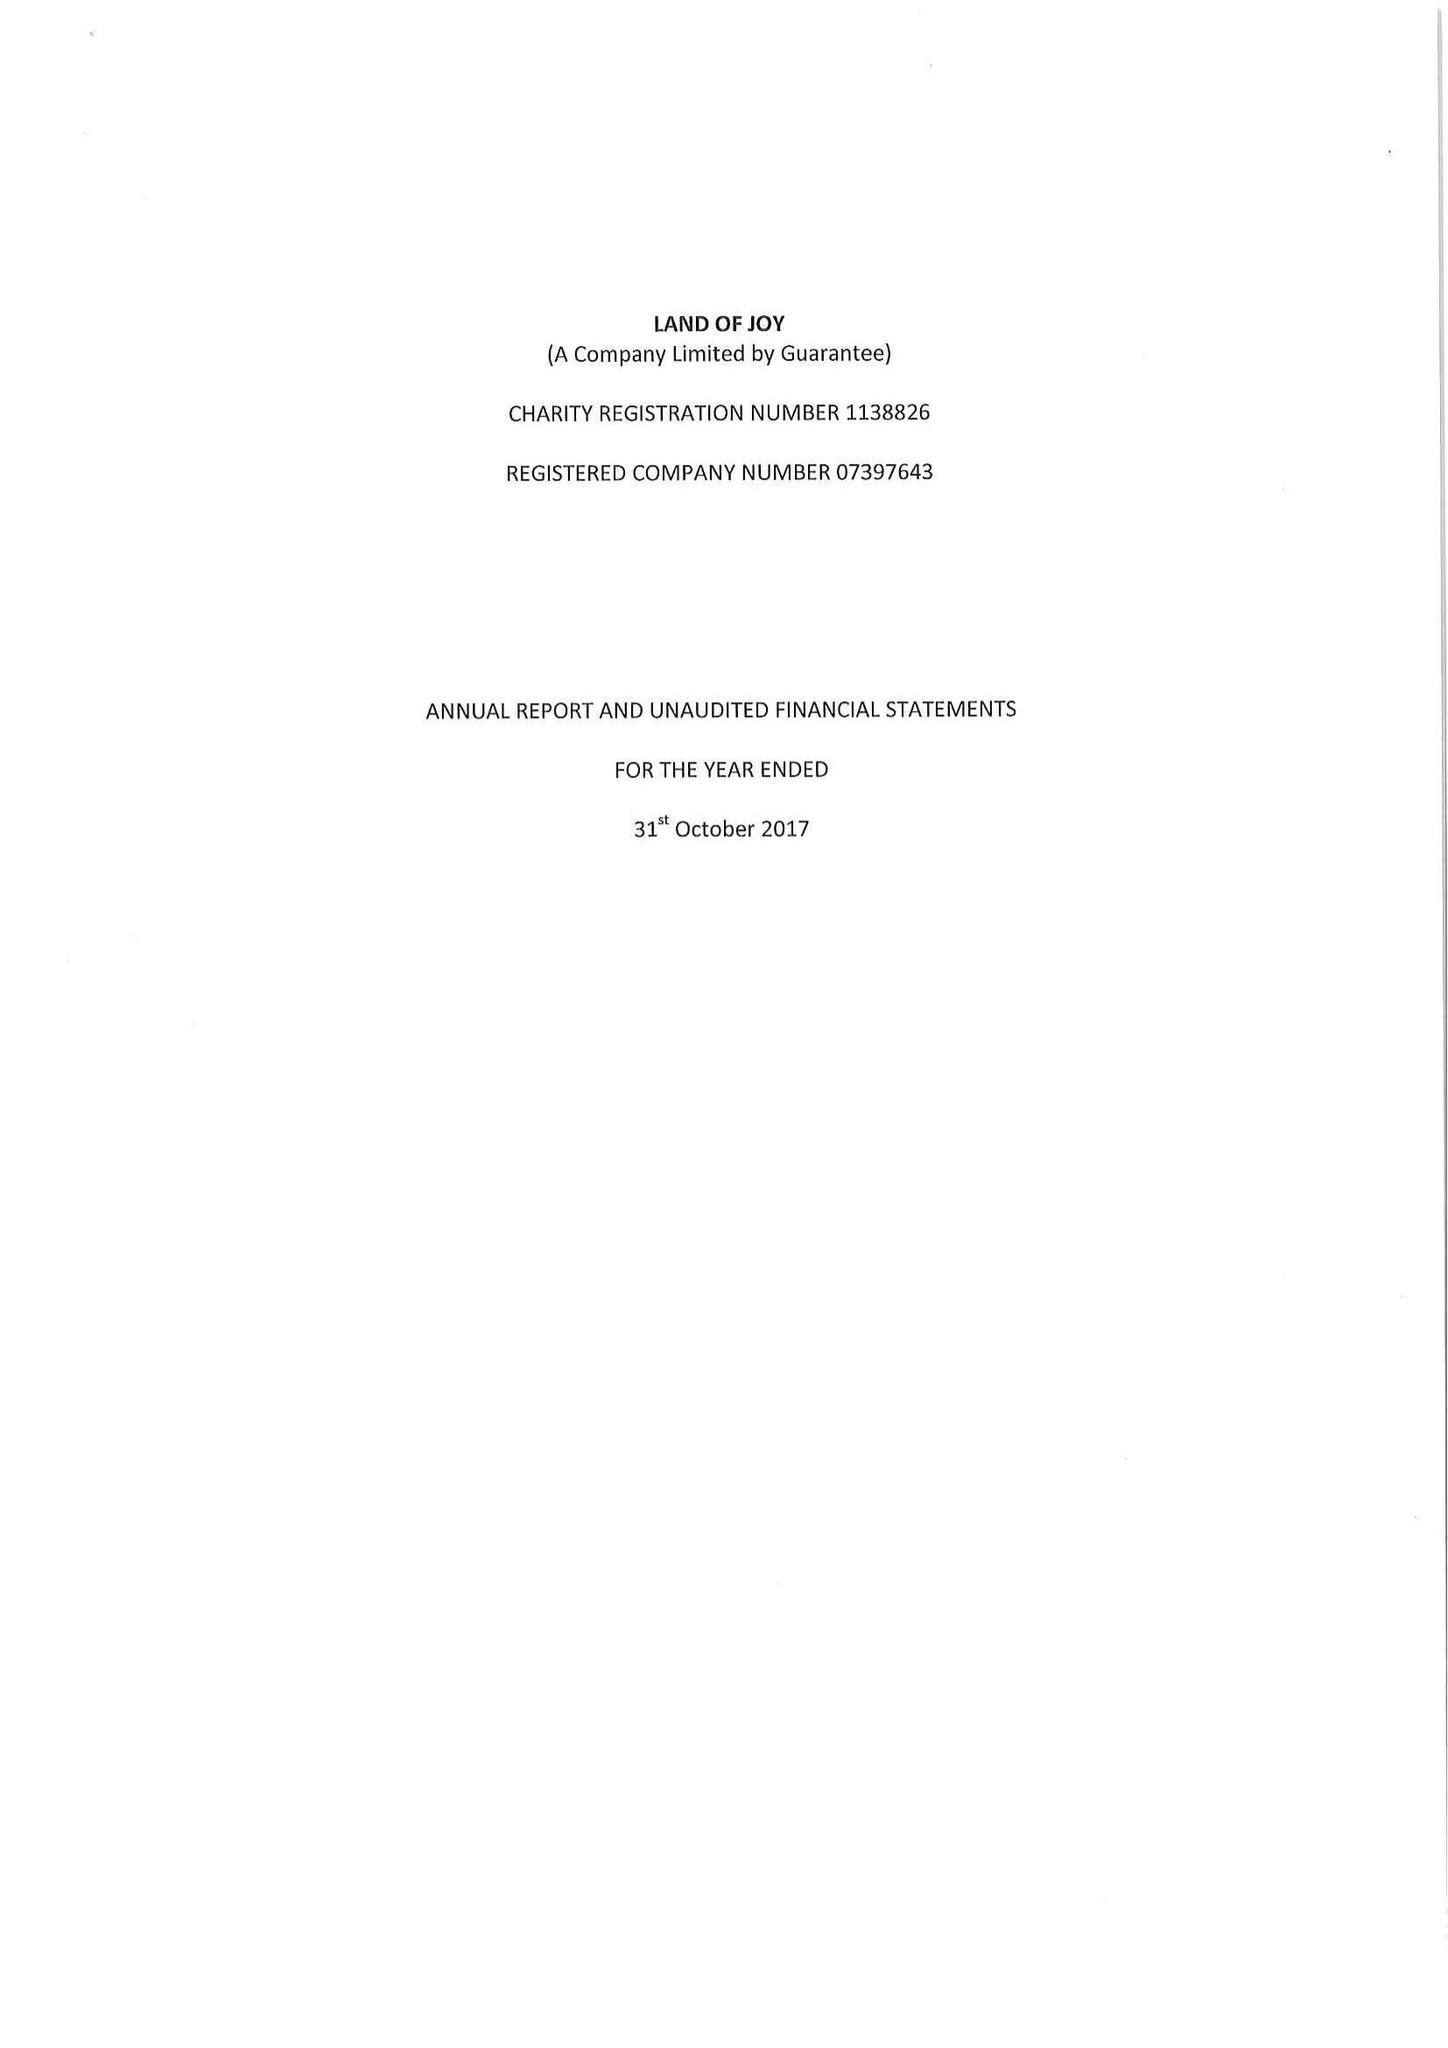What is the value for the address__street_line?
Answer the question using a single word or phrase. GREENHAUGH 